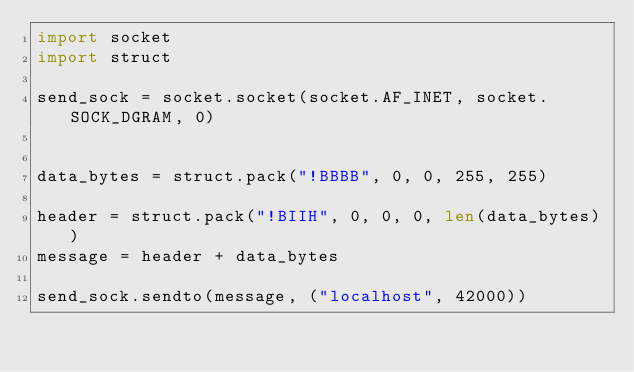Convert code to text. <code><loc_0><loc_0><loc_500><loc_500><_Python_>import socket
import struct

send_sock = socket.socket(socket.AF_INET, socket.SOCK_DGRAM, 0)


data_bytes = struct.pack("!BBBB", 0, 0, 255, 255)

header = struct.pack("!BIIH", 0, 0, 0, len(data_bytes))
message = header + data_bytes

send_sock.sendto(message, ("localhost", 42000))</code> 